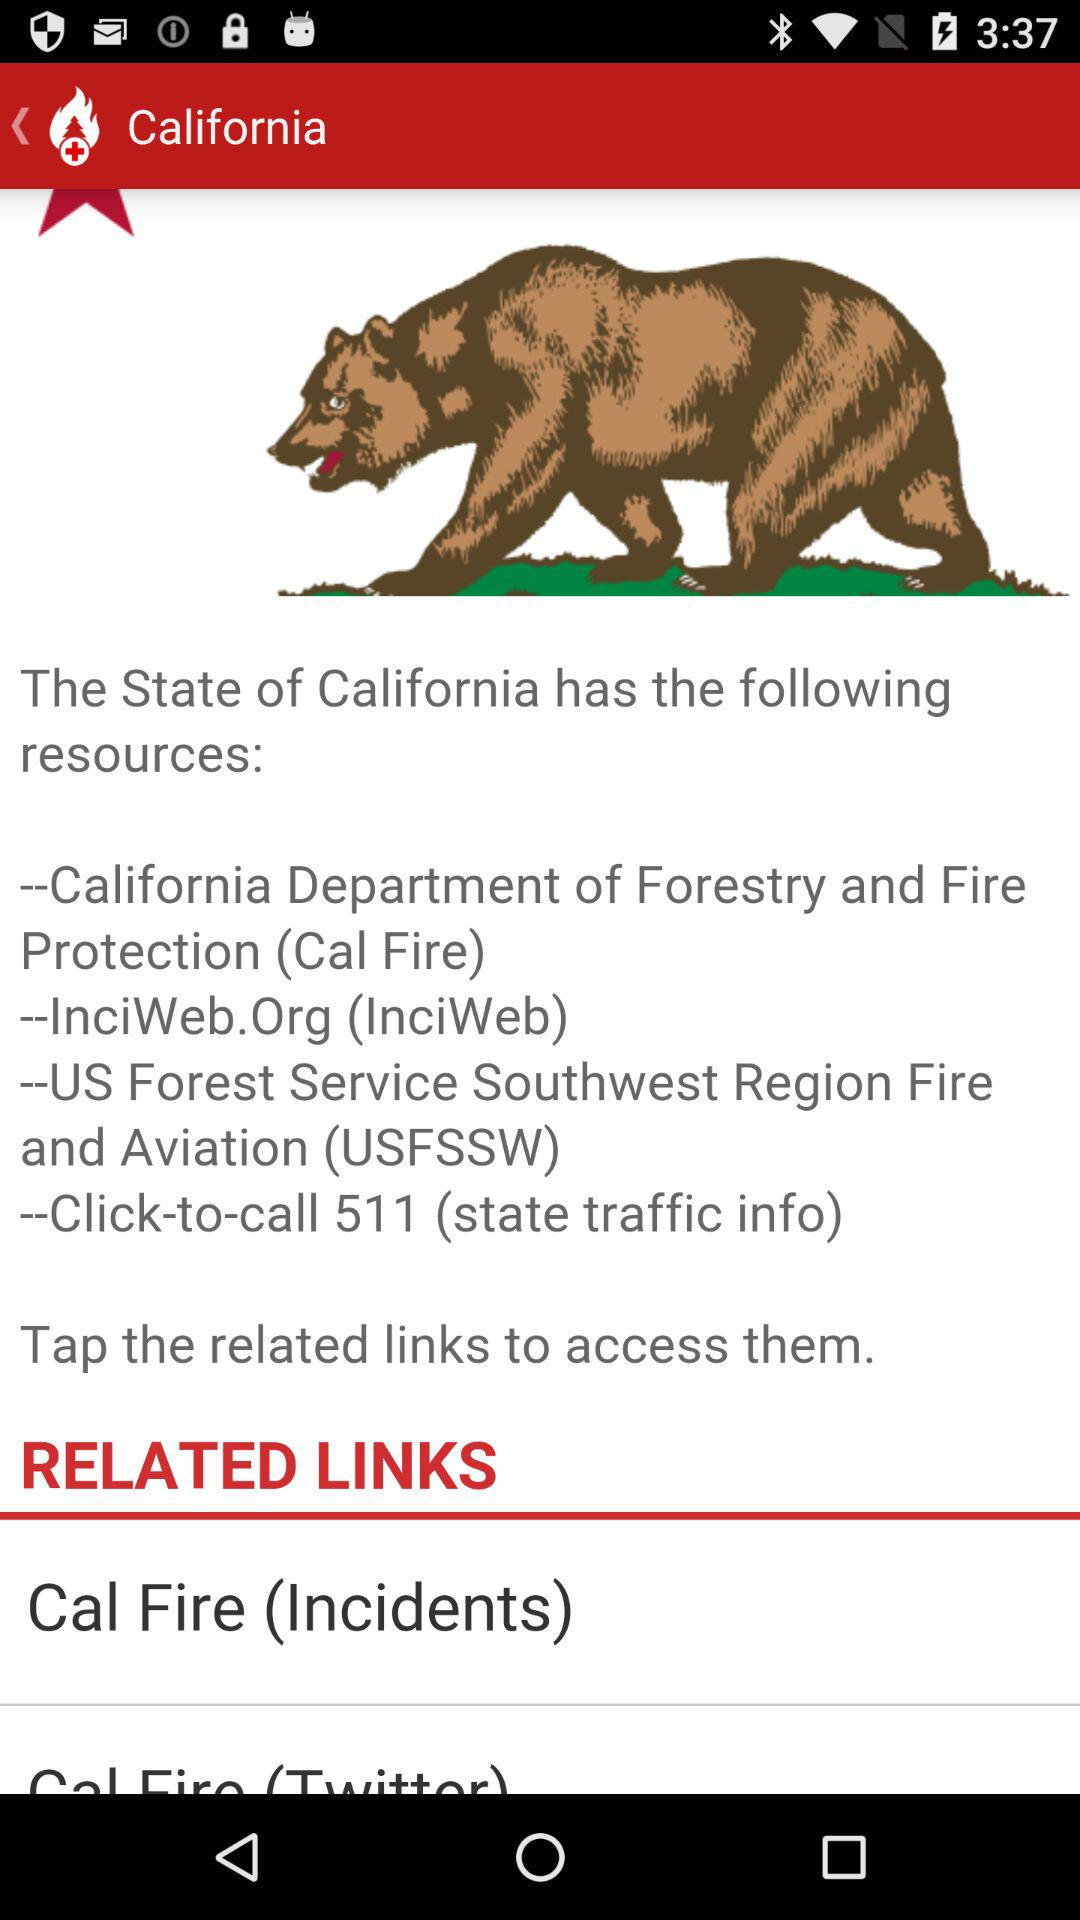What are the resources of the State of California? The resources of the State of California are "California Department of Forestry and Fire Protection (Cal Fire)", "InciWeb.Org (InciWeb)", "US Forest Service Southwest Region Fire and Aviation (USFSSW)" and "Click-to-call 511 (state traffic info)". 